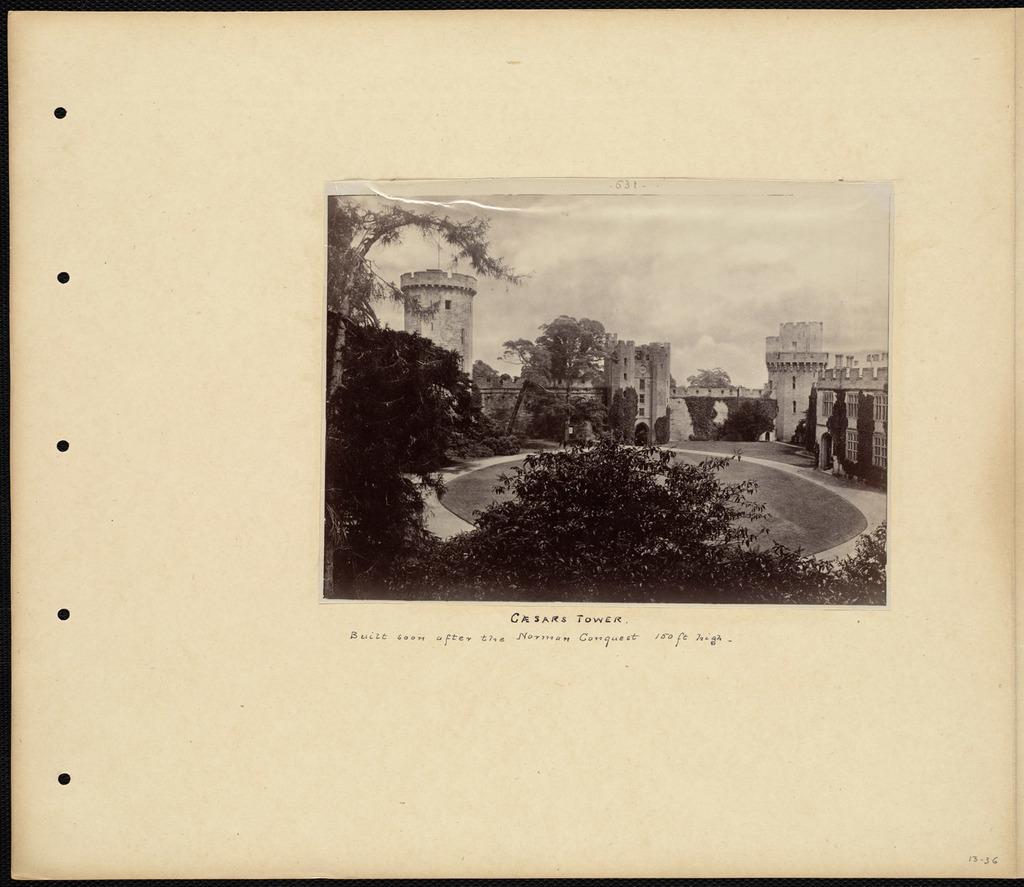Can you describe this image briefly? In this image we can see the sky, buildings, trees. We can see the information. It seems like the photo is pasted on a paper. 